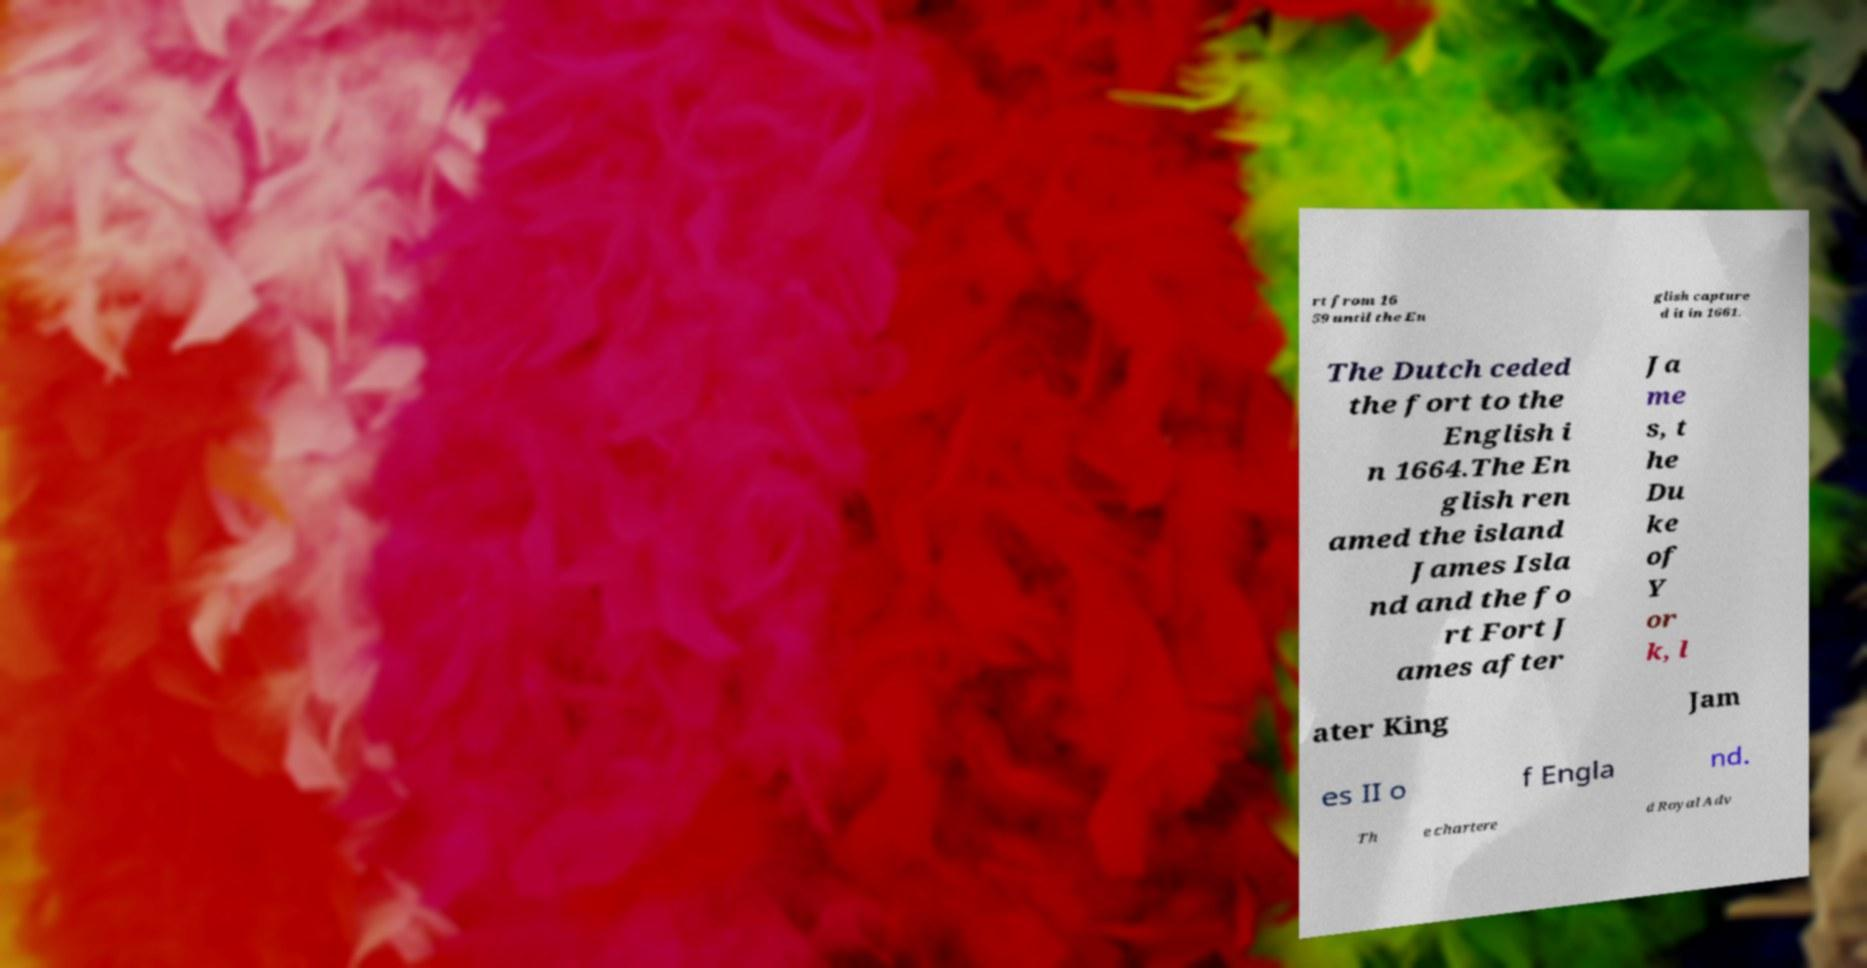Please identify and transcribe the text found in this image. rt from 16 59 until the En glish capture d it in 1661. The Dutch ceded the fort to the English i n 1664.The En glish ren amed the island James Isla nd and the fo rt Fort J ames after Ja me s, t he Du ke of Y or k, l ater King Jam es II o f Engla nd. Th e chartere d Royal Adv 